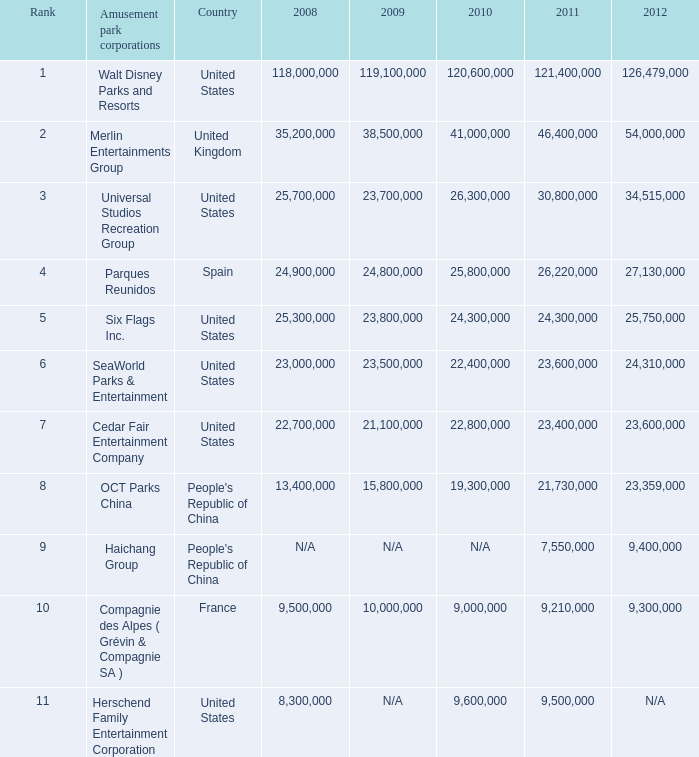In the United States the 2011 attendance at this amusement park corporation was larger than 30,800,000 but lists what as its 2008 attendance? 118000000.0. 